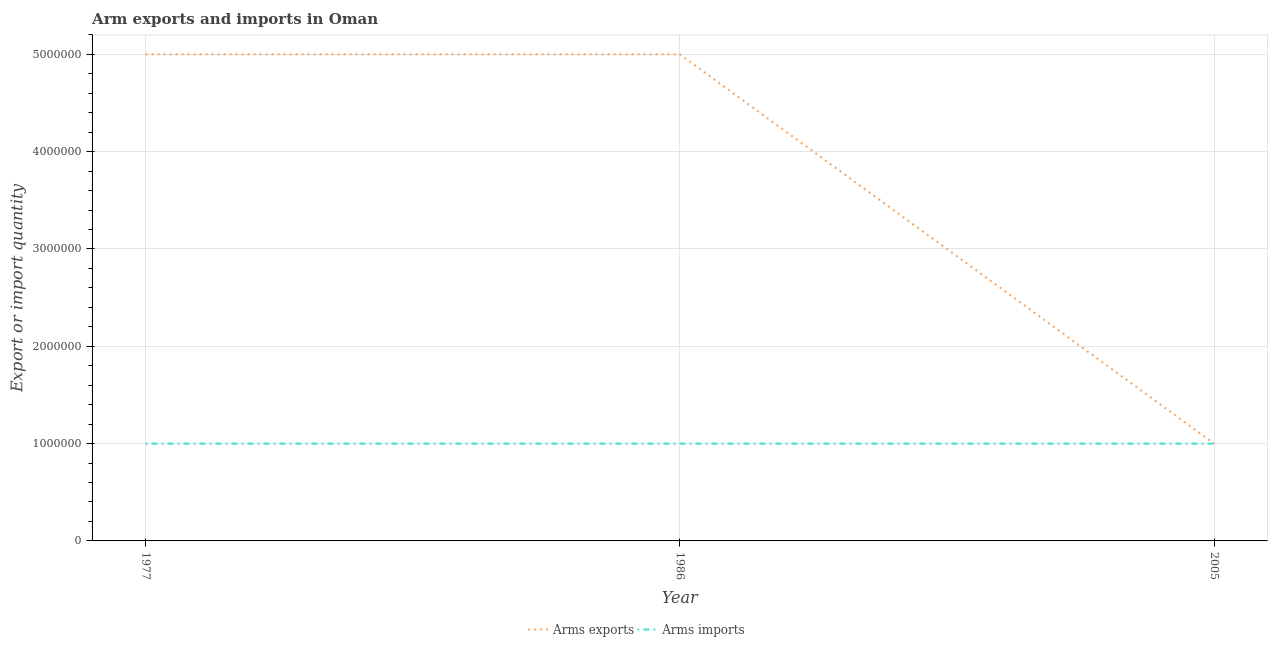Does the line corresponding to arms imports intersect with the line corresponding to arms exports?
Your answer should be very brief. Yes. What is the arms exports in 2005?
Provide a short and direct response. 1.00e+06. Across all years, what is the maximum arms imports?
Offer a terse response. 1.00e+06. Across all years, what is the minimum arms exports?
Give a very brief answer. 1.00e+06. In which year was the arms imports maximum?
Provide a short and direct response. 1977. What is the total arms imports in the graph?
Offer a terse response. 3.00e+06. What is the difference between the arms exports in 1986 and that in 2005?
Provide a succinct answer. 4.00e+06. What is the difference between the arms imports in 1986 and the arms exports in 2005?
Your answer should be very brief. 0. In the year 1986, what is the difference between the arms exports and arms imports?
Make the answer very short. 4.00e+06. What is the ratio of the arms imports in 1977 to that in 2005?
Offer a terse response. 1. What is the difference between the highest and the lowest arms exports?
Your answer should be compact. 4.00e+06. In how many years, is the arms exports greater than the average arms exports taken over all years?
Your answer should be very brief. 2. Is the sum of the arms exports in 1977 and 2005 greater than the maximum arms imports across all years?
Ensure brevity in your answer.  Yes. Does the graph contain grids?
Provide a succinct answer. Yes. Where does the legend appear in the graph?
Offer a very short reply. Bottom center. How many legend labels are there?
Your answer should be very brief. 2. What is the title of the graph?
Offer a terse response. Arm exports and imports in Oman. Does "Investment" appear as one of the legend labels in the graph?
Offer a terse response. No. What is the label or title of the Y-axis?
Your answer should be very brief. Export or import quantity. What is the Export or import quantity of Arms exports in 1977?
Your answer should be very brief. 5.00e+06. What is the Export or import quantity in Arms imports in 1977?
Provide a short and direct response. 1.00e+06. What is the Export or import quantity in Arms imports in 1986?
Give a very brief answer. 1.00e+06. What is the Export or import quantity in Arms exports in 2005?
Your answer should be very brief. 1.00e+06. Across all years, what is the maximum Export or import quantity in Arms exports?
Keep it short and to the point. 5.00e+06. Across all years, what is the minimum Export or import quantity of Arms exports?
Provide a succinct answer. 1.00e+06. What is the total Export or import quantity in Arms exports in the graph?
Keep it short and to the point. 1.10e+07. What is the difference between the Export or import quantity of Arms imports in 1977 and that in 1986?
Ensure brevity in your answer.  0. What is the difference between the Export or import quantity of Arms exports in 1977 and that in 2005?
Your answer should be compact. 4.00e+06. What is the difference between the Export or import quantity of Arms imports in 1977 and that in 2005?
Make the answer very short. 0. What is the difference between the Export or import quantity of Arms exports in 1977 and the Export or import quantity of Arms imports in 1986?
Ensure brevity in your answer.  4.00e+06. What is the difference between the Export or import quantity of Arms exports in 1986 and the Export or import quantity of Arms imports in 2005?
Provide a short and direct response. 4.00e+06. What is the average Export or import quantity in Arms exports per year?
Keep it short and to the point. 3.67e+06. In the year 1977, what is the difference between the Export or import quantity of Arms exports and Export or import quantity of Arms imports?
Make the answer very short. 4.00e+06. What is the ratio of the Export or import quantity of Arms exports in 1977 to that in 1986?
Your answer should be compact. 1. What is the ratio of the Export or import quantity of Arms imports in 1977 to that in 1986?
Offer a very short reply. 1. What is the ratio of the Export or import quantity of Arms exports in 1977 to that in 2005?
Offer a very short reply. 5. What is the ratio of the Export or import quantity of Arms imports in 1977 to that in 2005?
Provide a succinct answer. 1. What is the ratio of the Export or import quantity in Arms exports in 1986 to that in 2005?
Offer a terse response. 5. What is the difference between the highest and the second highest Export or import quantity in Arms exports?
Make the answer very short. 0. What is the difference between the highest and the second highest Export or import quantity of Arms imports?
Your answer should be compact. 0. What is the difference between the highest and the lowest Export or import quantity of Arms imports?
Make the answer very short. 0. 